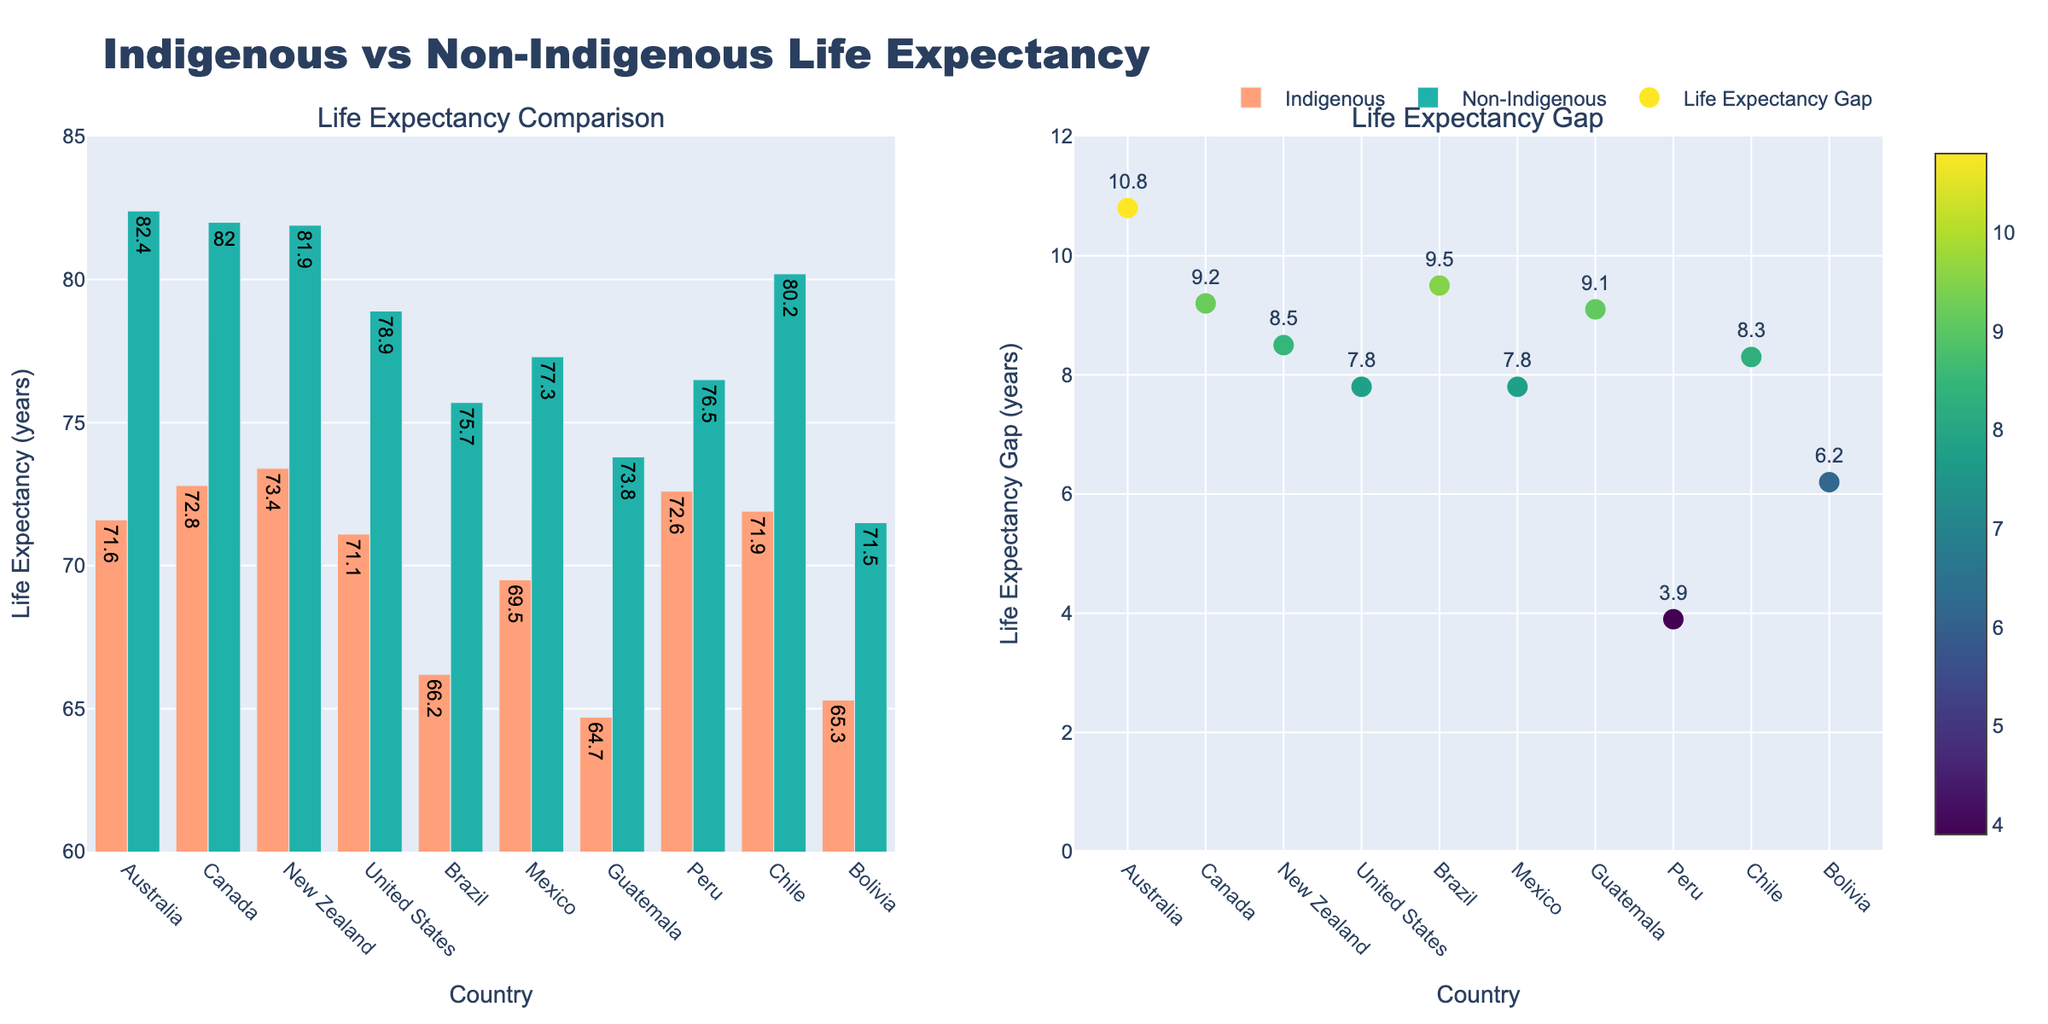How many subplots are there in the figure? The figure has two columns titled "Average Height" and "Average Weight", which means it contains two subplots.
Answer: 2 What is the title of the figure? The title is located at the top of the figure, reading "Drake University Football Team: Player Size Evolution (1950-2023)".
Answer: Drake University Football Team: Player Size Evolution (1950-2023) What is the range of the x-axis in the subplot for average height? The x-axis in the subplot for average height ranges from the minimum year to the maximum year, which is from 1950 to 2023.
Answer: 1950 to 2023 Which year had the highest average weight recorded? By looking at the line in the "Average Weight" subplot, the highest point on the y-axis corresponds to the year 2023 with a weight of 265 lbs.
Answer: 2023 How much did the average height increase from 1950 to 2023? The average height in 1950 was 71 inches, and in 2023 it was 77 inches. Subtracting these values gives the increase: 77 - 71 = 6 inches.
Answer: 6 inches On which subplot is the annotation "Go Bulldogs!" located? The annotation "Go Bulldogs!" is placed near the top-middle of the entire plot, which spans across both subplots.
Answer: Both What is the approximate rate of increase in average weight per decade? To find the rate of increase per decade, take the weight in 2023 (265 lbs) and subtract the weight in 1950 (195 lbs), then divide by the number of decades (7.3 decades). The calculation is (265 - 195) / 7.3 ≈ 9.59 lbs per decade.
Answer: Approximately 9.59 lbs per decade Is the increase in average height consistent over the years? By examining the plot for "Average Height", the height increases steadily over each decade without dips, indicating a consistent rise.
Answer: Yes Which year shows the largest single-decade increase in average weight? By examining the slope of the "Average Weight" line, the largest single-decade increase appears between 2000 and 2010, where the weight goes from 245 lbs to 255 lbs, which is an increase of 10 lbs.
Answer: Between 2000 and 2010 How does the average weight in 1980 compare to the average weight in 1960? The average weight in 1980 is shown as 225 lbs, while in 1960 it is 205 lbs. The difference is 225 - 205 = 20 lbs, indicating that the weight in 1980 is 20 lbs heavier than in 1960.
Answer: 20 lbs heavier 